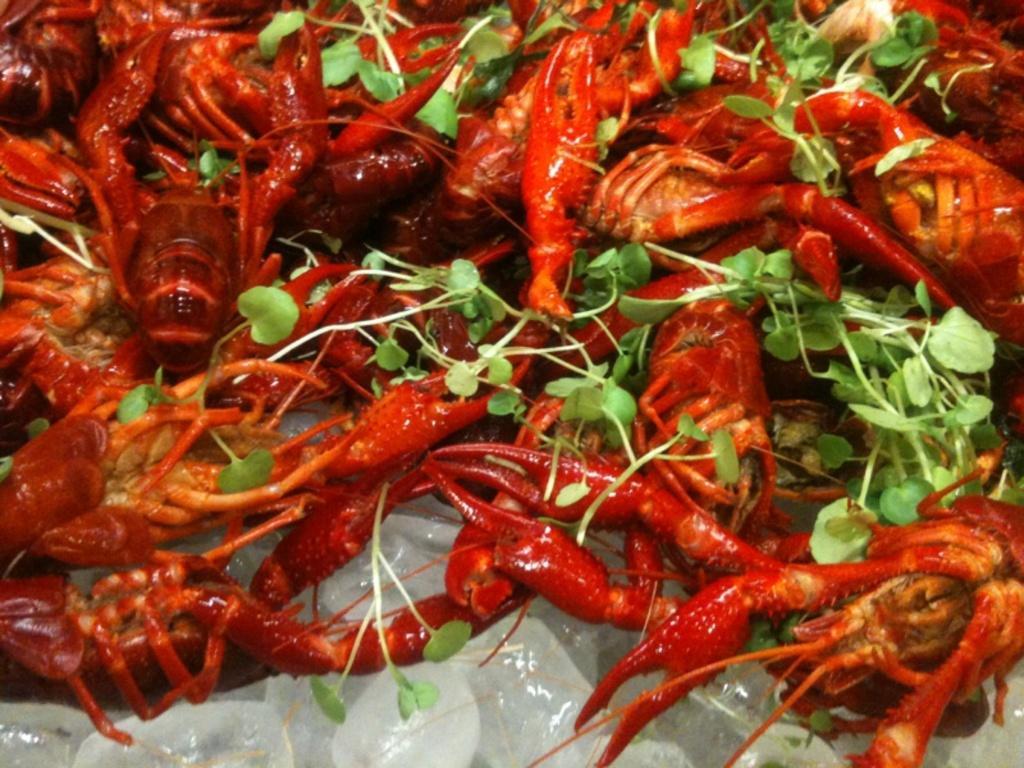Can you describe this image briefly? In this image we can see some food placed on the ice which is topped with some leafy vegetables. 